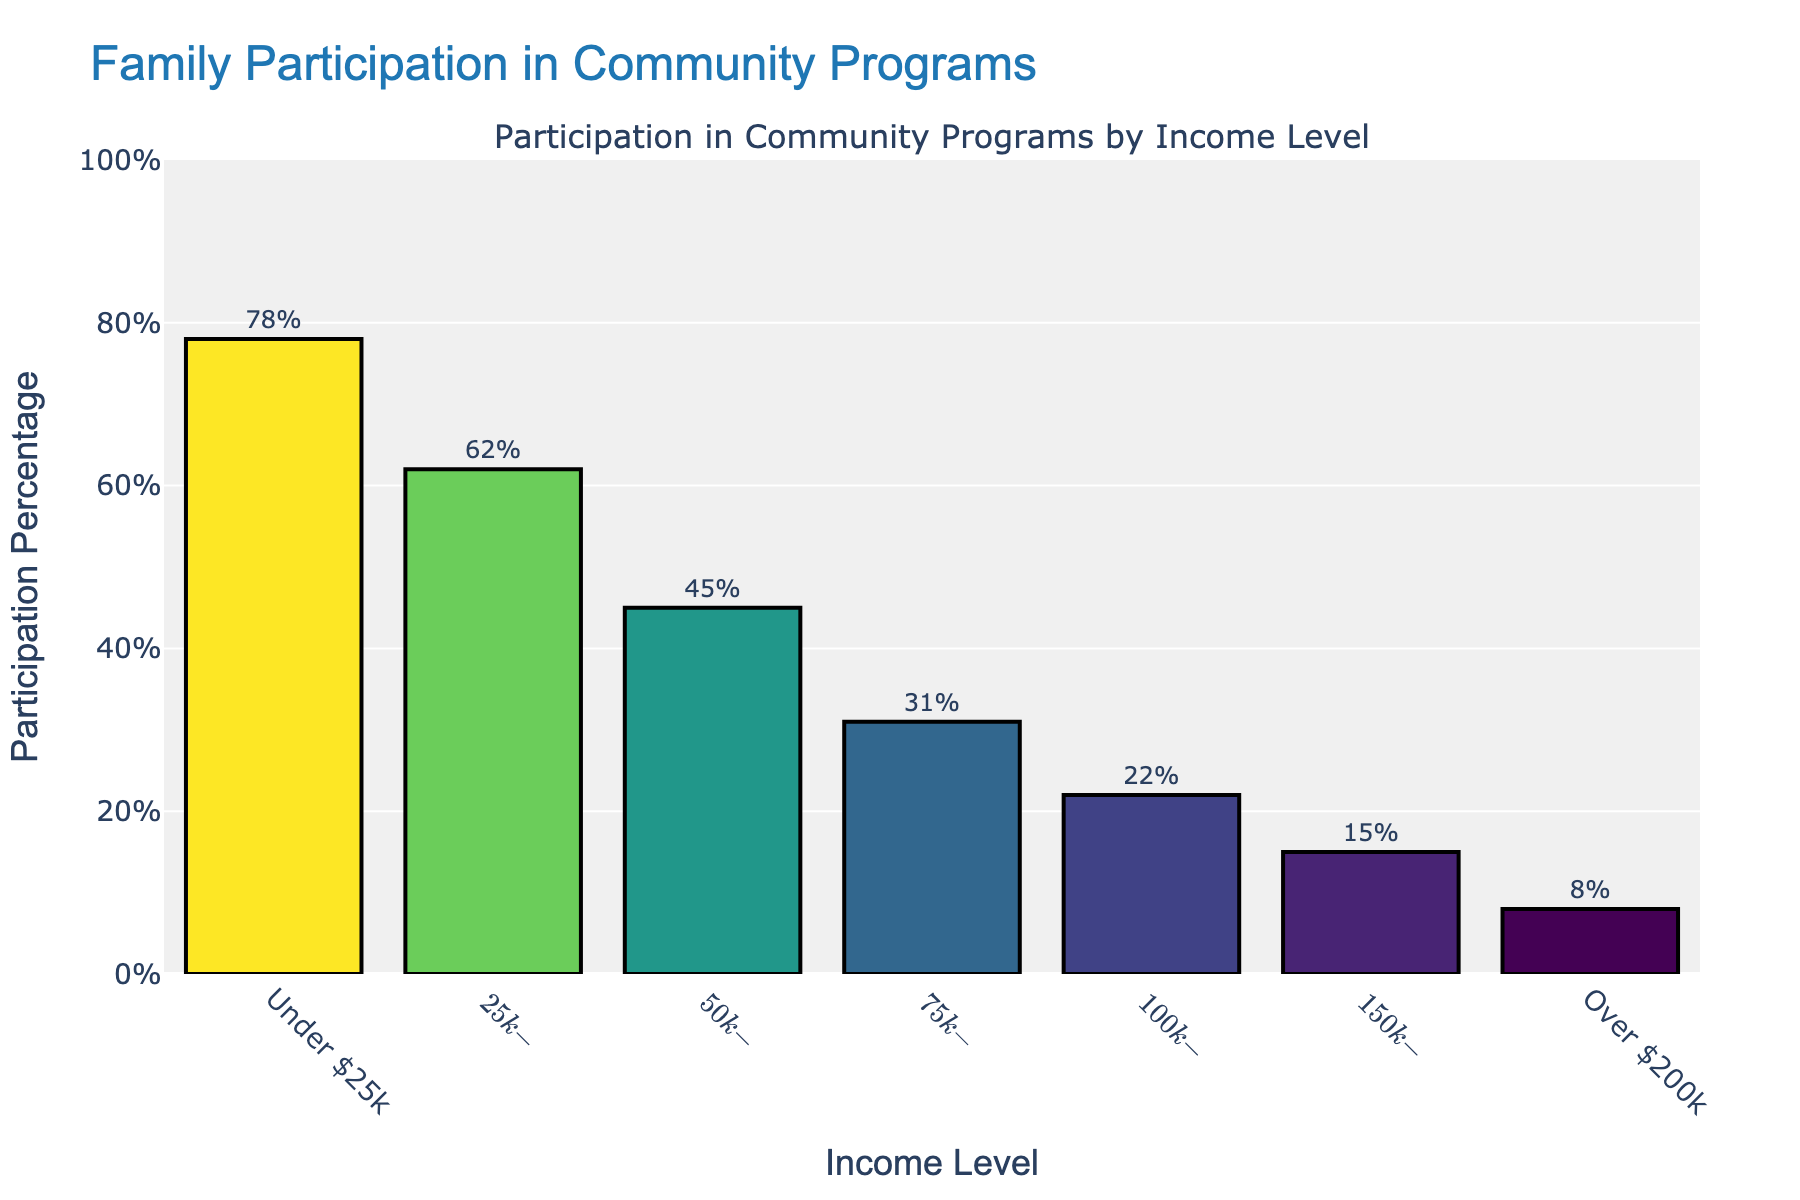Which income level has the highest participation percentage in community programs? The bar chart shows that the "Under $25k" income level has the highest participation percentage.
Answer: Under $25k Which income level has the lowest participation percentage in community programs? The bar chart shows that the "Over $200k" income level has the lowest participation percentage.
Answer: Over $200k What is the participation percentage difference between families with income "Under $25k" and families with income "$100k-$150k"? The participation percentage for "Under $25k" is 78%, and for "$100k-$150k" is 22%. The difference is 78 - 22 = 56%.
Answer: 56% Which income level shows a participation percentage closest to 50%? The bar chart indicates that the "$50k-$75k" income level has a participation percentage of 45%, which is the closest to 50%.
Answer: $50k-$75k How many income levels have a participation percentage below 40%? The bar chart shows income levels "$75k-$100k", "$100k-$150k", "$150k-$200k", and "Over $200k" have participation percentages of 31%, 22%, 15%, and 8%, respectively. In total, there are 4 income levels below 40%.
Answer: 4 What is the range of participation percentages shown in the bar chart? The highest participation percentage is 78% (Under $25k) and the lowest is 8% (Over $200k). The range is 78 - 8 = 70%.
Answer: 70% Compare the participation percentages of the index levels "$25k-$50k" and "$50k-$75k". Which one is higher and by how much? The participation percentage for "$25k-$50k" is 62%, and for "$50k-$75k" is 45%. The difference is 62 - 45 = 17%. "$25k-$50k" is higher by 17%.
Answer: $25k-$50k by 17% What is the sum of the participation percentages for families with income levels "Under $25k" and "$50k-$75k"? The participation percentage for "Under $25k" is 78%, and for "$50k-$75k" is 45%. The sum is 78 + 45 = 123%.
Answer: 123% If we consider income levels below $75k, what is the average participation percentage in community programs? Income levels below $75k are "Under $25k", "$25k-$50k", and "$50k-$75k" with participation percentages of 78%, 62%, and 45% respectively. Average = (78 + 62 + 45)/3 ≈ 61.67%.
Answer: 61.67% 